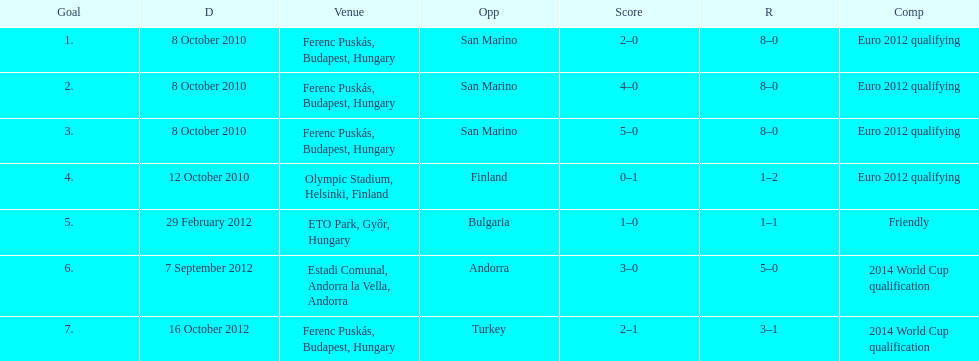How many consecutive games were goals were against san marino? 3. 